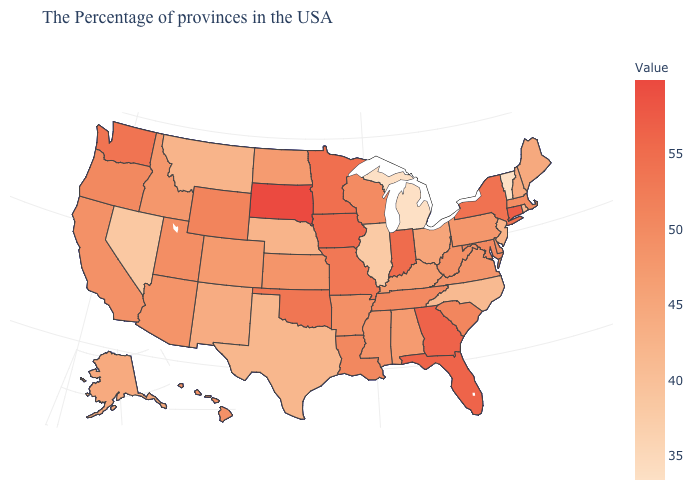Among the states that border Oregon , does California have the lowest value?
Give a very brief answer. No. Does the map have missing data?
Be succinct. No. Among the states that border Georgia , which have the lowest value?
Short answer required. North Carolina. Does Vermont have the lowest value in the USA?
Be succinct. Yes. Does the map have missing data?
Answer briefly. No. Does Wyoming have a lower value than Iowa?
Keep it brief. Yes. Which states have the lowest value in the USA?
Keep it brief. Vermont, Michigan. Among the states that border Pennsylvania , does New York have the highest value?
Write a very short answer. Yes. 